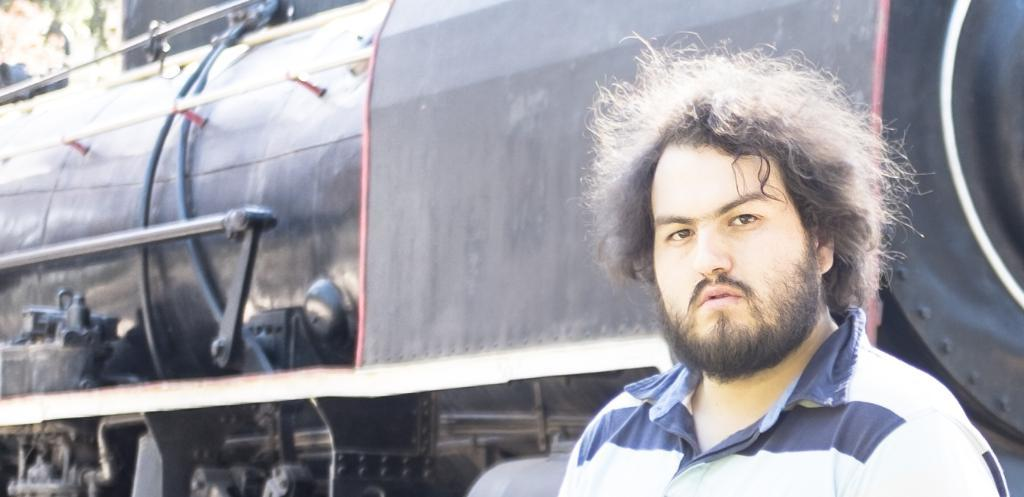Who is present in the image? There is a man in the image. What is the man wearing? The man is wearing a t-shirt. What can be seen near the man in the image? The man is standing near a train. What parts of the train are visible in the image? The train's wheel and other parts are visible. What is located in the top left corner of the image? There is a tree in the top left corner of the image. How does the man show respect to the turkey in the image? There is no turkey present in the image, so the man cannot show respect to a turkey. 